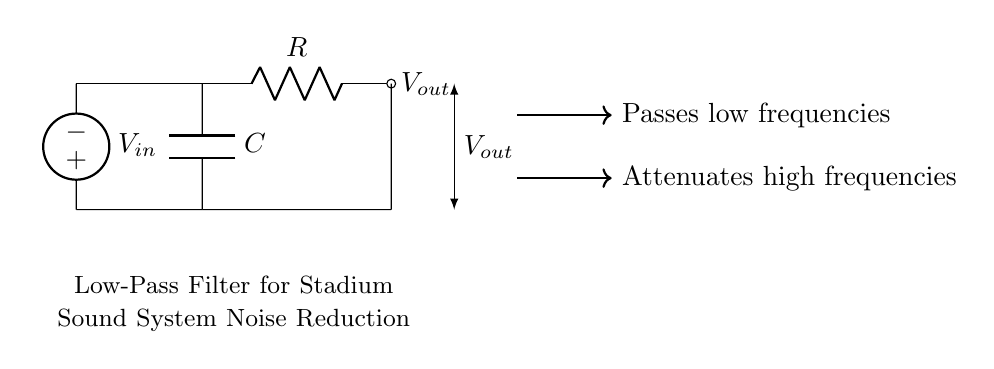What is the name of this circuit? The circuit is labeled as a "Low-Pass Filter for Stadium Sound System Noise Reduction," indicating its purpose is to reduce noise while allowing low frequencies to pass.
Answer: Low-Pass Filter What components are used in this circuit? The circuit contains a resistor and a capacitor, which are standard components in a low-pass filter configuration. They are represented by R and C in the diagram.
Answer: Resistor and Capacitor What is the output voltage node labeled as? The output voltage is labeled as V out on the diagram, indicating where the filtered audio signal is taken from the circuit.
Answer: V out Which frequency type does the filter pass? The diagram specifies that the filter "Passes low frequencies," indicating its function to allow low-frequency signals to pass through the output node while attenuating higher frequencies.
Answer: Low frequencies What happens to high frequencies in this circuit? The circuit diagram notes that it "Attenuates high frequencies," meaning it reduces or diminishes the amplitude of high-frequency signals, which is a key characteristic of a low-pass filter.
Answer: Attenuates What is the input voltage node labeled as? The input voltage for the circuit is labeled as V in, which shows where the audio signal enters the filter before processing.
Answer: V in What is the purpose of the capacitor in this circuit? The capacitor's role in the circuit is to store and release energy, which helps determine the cut-off frequency of the filter. This is crucial for defining which frequencies can pass to the output.
Answer: To determine the cut-off frequency 